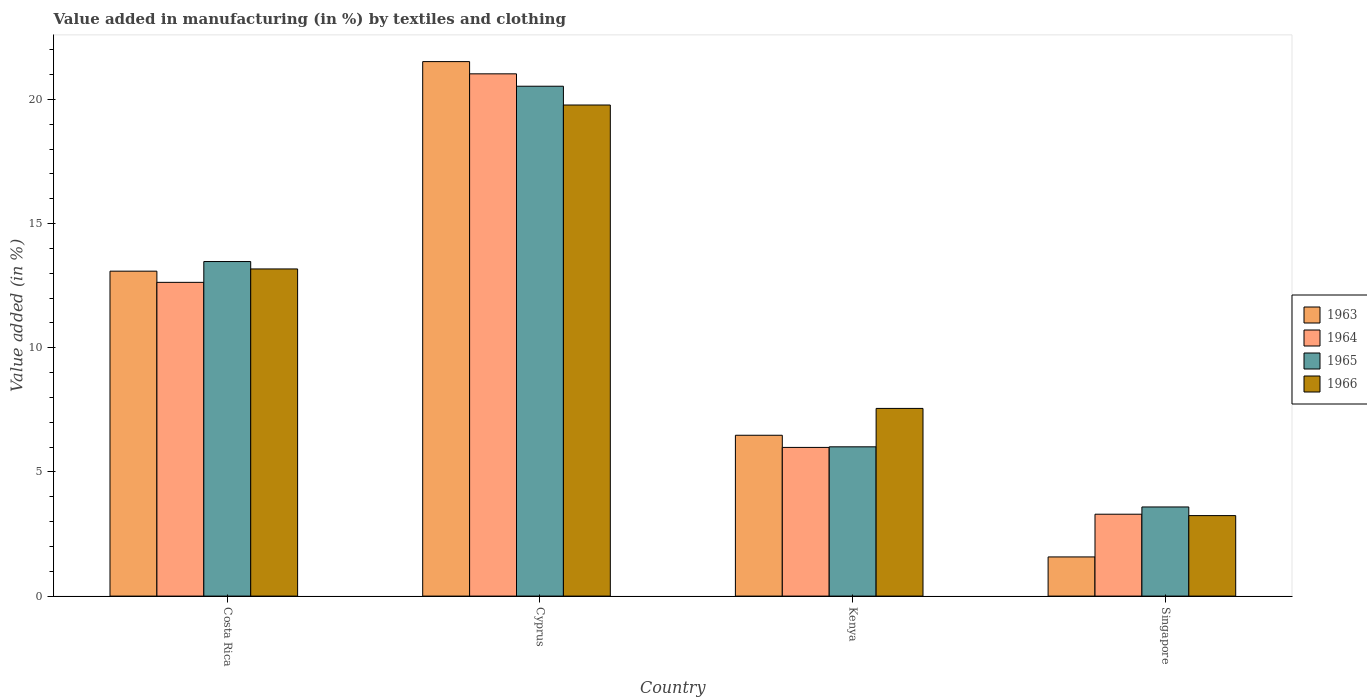How many bars are there on the 1st tick from the left?
Provide a succinct answer. 4. How many bars are there on the 3rd tick from the right?
Ensure brevity in your answer.  4. What is the label of the 1st group of bars from the left?
Your answer should be compact. Costa Rica. In how many cases, is the number of bars for a given country not equal to the number of legend labels?
Give a very brief answer. 0. What is the percentage of value added in manufacturing by textiles and clothing in 1964 in Kenya?
Give a very brief answer. 5.99. Across all countries, what is the maximum percentage of value added in manufacturing by textiles and clothing in 1965?
Keep it short and to the point. 20.53. Across all countries, what is the minimum percentage of value added in manufacturing by textiles and clothing in 1965?
Make the answer very short. 3.59. In which country was the percentage of value added in manufacturing by textiles and clothing in 1964 maximum?
Offer a terse response. Cyprus. In which country was the percentage of value added in manufacturing by textiles and clothing in 1965 minimum?
Provide a succinct answer. Singapore. What is the total percentage of value added in manufacturing by textiles and clothing in 1964 in the graph?
Give a very brief answer. 42.95. What is the difference between the percentage of value added in manufacturing by textiles and clothing in 1965 in Cyprus and that in Kenya?
Ensure brevity in your answer.  14.52. What is the difference between the percentage of value added in manufacturing by textiles and clothing in 1964 in Costa Rica and the percentage of value added in manufacturing by textiles and clothing in 1965 in Cyprus?
Provide a short and direct response. -7.9. What is the average percentage of value added in manufacturing by textiles and clothing in 1966 per country?
Offer a terse response. 10.94. What is the difference between the percentage of value added in manufacturing by textiles and clothing of/in 1963 and percentage of value added in manufacturing by textiles and clothing of/in 1964 in Cyprus?
Offer a very short reply. 0.49. In how many countries, is the percentage of value added in manufacturing by textiles and clothing in 1965 greater than 6 %?
Offer a terse response. 3. What is the ratio of the percentage of value added in manufacturing by textiles and clothing in 1964 in Costa Rica to that in Kenya?
Offer a very short reply. 2.11. Is the percentage of value added in manufacturing by textiles and clothing in 1966 in Cyprus less than that in Singapore?
Make the answer very short. No. What is the difference between the highest and the second highest percentage of value added in manufacturing by textiles and clothing in 1964?
Offer a very short reply. -6.65. What is the difference between the highest and the lowest percentage of value added in manufacturing by textiles and clothing in 1963?
Ensure brevity in your answer.  19.95. In how many countries, is the percentage of value added in manufacturing by textiles and clothing in 1965 greater than the average percentage of value added in manufacturing by textiles and clothing in 1965 taken over all countries?
Keep it short and to the point. 2. Is the sum of the percentage of value added in manufacturing by textiles and clothing in 1965 in Cyprus and Singapore greater than the maximum percentage of value added in manufacturing by textiles and clothing in 1964 across all countries?
Your response must be concise. Yes. What does the 2nd bar from the left in Singapore represents?
Offer a terse response. 1964. How many bars are there?
Ensure brevity in your answer.  16. Are all the bars in the graph horizontal?
Offer a very short reply. No. How many countries are there in the graph?
Provide a succinct answer. 4. Does the graph contain any zero values?
Keep it short and to the point. No. Does the graph contain grids?
Offer a terse response. No. Where does the legend appear in the graph?
Provide a succinct answer. Center right. How are the legend labels stacked?
Offer a terse response. Vertical. What is the title of the graph?
Your answer should be very brief. Value added in manufacturing (in %) by textiles and clothing. Does "1966" appear as one of the legend labels in the graph?
Provide a succinct answer. Yes. What is the label or title of the X-axis?
Provide a succinct answer. Country. What is the label or title of the Y-axis?
Provide a short and direct response. Value added (in %). What is the Value added (in %) of 1963 in Costa Rica?
Your response must be concise. 13.08. What is the Value added (in %) in 1964 in Costa Rica?
Ensure brevity in your answer.  12.63. What is the Value added (in %) of 1965 in Costa Rica?
Offer a very short reply. 13.47. What is the Value added (in %) in 1966 in Costa Rica?
Keep it short and to the point. 13.17. What is the Value added (in %) in 1963 in Cyprus?
Give a very brief answer. 21.52. What is the Value added (in %) of 1964 in Cyprus?
Give a very brief answer. 21.03. What is the Value added (in %) in 1965 in Cyprus?
Your answer should be very brief. 20.53. What is the Value added (in %) in 1966 in Cyprus?
Offer a very short reply. 19.78. What is the Value added (in %) in 1963 in Kenya?
Offer a very short reply. 6.48. What is the Value added (in %) of 1964 in Kenya?
Provide a short and direct response. 5.99. What is the Value added (in %) of 1965 in Kenya?
Provide a succinct answer. 6.01. What is the Value added (in %) of 1966 in Kenya?
Offer a very short reply. 7.56. What is the Value added (in %) in 1963 in Singapore?
Offer a terse response. 1.58. What is the Value added (in %) of 1964 in Singapore?
Give a very brief answer. 3.3. What is the Value added (in %) of 1965 in Singapore?
Make the answer very short. 3.59. What is the Value added (in %) of 1966 in Singapore?
Keep it short and to the point. 3.24. Across all countries, what is the maximum Value added (in %) in 1963?
Make the answer very short. 21.52. Across all countries, what is the maximum Value added (in %) of 1964?
Make the answer very short. 21.03. Across all countries, what is the maximum Value added (in %) in 1965?
Provide a short and direct response. 20.53. Across all countries, what is the maximum Value added (in %) in 1966?
Give a very brief answer. 19.78. Across all countries, what is the minimum Value added (in %) in 1963?
Offer a very short reply. 1.58. Across all countries, what is the minimum Value added (in %) in 1964?
Offer a terse response. 3.3. Across all countries, what is the minimum Value added (in %) of 1965?
Your response must be concise. 3.59. Across all countries, what is the minimum Value added (in %) in 1966?
Your response must be concise. 3.24. What is the total Value added (in %) of 1963 in the graph?
Offer a very short reply. 42.66. What is the total Value added (in %) in 1964 in the graph?
Your answer should be compact. 42.95. What is the total Value added (in %) of 1965 in the graph?
Provide a short and direct response. 43.6. What is the total Value added (in %) in 1966 in the graph?
Ensure brevity in your answer.  43.75. What is the difference between the Value added (in %) of 1963 in Costa Rica and that in Cyprus?
Keep it short and to the point. -8.44. What is the difference between the Value added (in %) in 1964 in Costa Rica and that in Cyprus?
Offer a terse response. -8.4. What is the difference between the Value added (in %) of 1965 in Costa Rica and that in Cyprus?
Keep it short and to the point. -7.06. What is the difference between the Value added (in %) of 1966 in Costa Rica and that in Cyprus?
Your answer should be compact. -6.6. What is the difference between the Value added (in %) in 1963 in Costa Rica and that in Kenya?
Offer a very short reply. 6.61. What is the difference between the Value added (in %) in 1964 in Costa Rica and that in Kenya?
Ensure brevity in your answer.  6.65. What is the difference between the Value added (in %) in 1965 in Costa Rica and that in Kenya?
Ensure brevity in your answer.  7.46. What is the difference between the Value added (in %) in 1966 in Costa Rica and that in Kenya?
Provide a short and direct response. 5.62. What is the difference between the Value added (in %) in 1963 in Costa Rica and that in Singapore?
Offer a very short reply. 11.51. What is the difference between the Value added (in %) of 1964 in Costa Rica and that in Singapore?
Provide a short and direct response. 9.34. What is the difference between the Value added (in %) of 1965 in Costa Rica and that in Singapore?
Your response must be concise. 9.88. What is the difference between the Value added (in %) of 1966 in Costa Rica and that in Singapore?
Ensure brevity in your answer.  9.93. What is the difference between the Value added (in %) in 1963 in Cyprus and that in Kenya?
Ensure brevity in your answer.  15.05. What is the difference between the Value added (in %) of 1964 in Cyprus and that in Kenya?
Offer a very short reply. 15.04. What is the difference between the Value added (in %) of 1965 in Cyprus and that in Kenya?
Provide a succinct answer. 14.52. What is the difference between the Value added (in %) in 1966 in Cyprus and that in Kenya?
Keep it short and to the point. 12.22. What is the difference between the Value added (in %) of 1963 in Cyprus and that in Singapore?
Provide a short and direct response. 19.95. What is the difference between the Value added (in %) in 1964 in Cyprus and that in Singapore?
Offer a terse response. 17.73. What is the difference between the Value added (in %) of 1965 in Cyprus and that in Singapore?
Make the answer very short. 16.94. What is the difference between the Value added (in %) of 1966 in Cyprus and that in Singapore?
Your answer should be compact. 16.53. What is the difference between the Value added (in %) in 1963 in Kenya and that in Singapore?
Your answer should be compact. 4.9. What is the difference between the Value added (in %) of 1964 in Kenya and that in Singapore?
Ensure brevity in your answer.  2.69. What is the difference between the Value added (in %) in 1965 in Kenya and that in Singapore?
Provide a succinct answer. 2.42. What is the difference between the Value added (in %) in 1966 in Kenya and that in Singapore?
Provide a short and direct response. 4.32. What is the difference between the Value added (in %) of 1963 in Costa Rica and the Value added (in %) of 1964 in Cyprus?
Your answer should be compact. -7.95. What is the difference between the Value added (in %) of 1963 in Costa Rica and the Value added (in %) of 1965 in Cyprus?
Make the answer very short. -7.45. What is the difference between the Value added (in %) in 1963 in Costa Rica and the Value added (in %) in 1966 in Cyprus?
Offer a very short reply. -6.69. What is the difference between the Value added (in %) in 1964 in Costa Rica and the Value added (in %) in 1965 in Cyprus?
Provide a short and direct response. -7.9. What is the difference between the Value added (in %) of 1964 in Costa Rica and the Value added (in %) of 1966 in Cyprus?
Offer a terse response. -7.14. What is the difference between the Value added (in %) in 1965 in Costa Rica and the Value added (in %) in 1966 in Cyprus?
Your response must be concise. -6.3. What is the difference between the Value added (in %) of 1963 in Costa Rica and the Value added (in %) of 1964 in Kenya?
Provide a succinct answer. 7.1. What is the difference between the Value added (in %) of 1963 in Costa Rica and the Value added (in %) of 1965 in Kenya?
Offer a very short reply. 7.07. What is the difference between the Value added (in %) in 1963 in Costa Rica and the Value added (in %) in 1966 in Kenya?
Keep it short and to the point. 5.53. What is the difference between the Value added (in %) of 1964 in Costa Rica and the Value added (in %) of 1965 in Kenya?
Make the answer very short. 6.62. What is the difference between the Value added (in %) in 1964 in Costa Rica and the Value added (in %) in 1966 in Kenya?
Your answer should be very brief. 5.08. What is the difference between the Value added (in %) in 1965 in Costa Rica and the Value added (in %) in 1966 in Kenya?
Offer a very short reply. 5.91. What is the difference between the Value added (in %) of 1963 in Costa Rica and the Value added (in %) of 1964 in Singapore?
Your answer should be compact. 9.79. What is the difference between the Value added (in %) in 1963 in Costa Rica and the Value added (in %) in 1965 in Singapore?
Give a very brief answer. 9.5. What is the difference between the Value added (in %) in 1963 in Costa Rica and the Value added (in %) in 1966 in Singapore?
Ensure brevity in your answer.  9.84. What is the difference between the Value added (in %) of 1964 in Costa Rica and the Value added (in %) of 1965 in Singapore?
Keep it short and to the point. 9.04. What is the difference between the Value added (in %) in 1964 in Costa Rica and the Value added (in %) in 1966 in Singapore?
Keep it short and to the point. 9.39. What is the difference between the Value added (in %) of 1965 in Costa Rica and the Value added (in %) of 1966 in Singapore?
Your answer should be compact. 10.23. What is the difference between the Value added (in %) in 1963 in Cyprus and the Value added (in %) in 1964 in Kenya?
Give a very brief answer. 15.54. What is the difference between the Value added (in %) of 1963 in Cyprus and the Value added (in %) of 1965 in Kenya?
Make the answer very short. 15.51. What is the difference between the Value added (in %) in 1963 in Cyprus and the Value added (in %) in 1966 in Kenya?
Your answer should be very brief. 13.97. What is the difference between the Value added (in %) of 1964 in Cyprus and the Value added (in %) of 1965 in Kenya?
Keep it short and to the point. 15.02. What is the difference between the Value added (in %) of 1964 in Cyprus and the Value added (in %) of 1966 in Kenya?
Provide a succinct answer. 13.47. What is the difference between the Value added (in %) of 1965 in Cyprus and the Value added (in %) of 1966 in Kenya?
Offer a terse response. 12.97. What is the difference between the Value added (in %) of 1963 in Cyprus and the Value added (in %) of 1964 in Singapore?
Offer a terse response. 18.23. What is the difference between the Value added (in %) of 1963 in Cyprus and the Value added (in %) of 1965 in Singapore?
Provide a succinct answer. 17.93. What is the difference between the Value added (in %) in 1963 in Cyprus and the Value added (in %) in 1966 in Singapore?
Your response must be concise. 18.28. What is the difference between the Value added (in %) in 1964 in Cyprus and the Value added (in %) in 1965 in Singapore?
Give a very brief answer. 17.44. What is the difference between the Value added (in %) in 1964 in Cyprus and the Value added (in %) in 1966 in Singapore?
Your answer should be very brief. 17.79. What is the difference between the Value added (in %) of 1965 in Cyprus and the Value added (in %) of 1966 in Singapore?
Provide a short and direct response. 17.29. What is the difference between the Value added (in %) of 1963 in Kenya and the Value added (in %) of 1964 in Singapore?
Your answer should be compact. 3.18. What is the difference between the Value added (in %) of 1963 in Kenya and the Value added (in %) of 1965 in Singapore?
Offer a terse response. 2.89. What is the difference between the Value added (in %) of 1963 in Kenya and the Value added (in %) of 1966 in Singapore?
Your answer should be very brief. 3.24. What is the difference between the Value added (in %) in 1964 in Kenya and the Value added (in %) in 1965 in Singapore?
Your response must be concise. 2.4. What is the difference between the Value added (in %) in 1964 in Kenya and the Value added (in %) in 1966 in Singapore?
Offer a terse response. 2.75. What is the difference between the Value added (in %) in 1965 in Kenya and the Value added (in %) in 1966 in Singapore?
Ensure brevity in your answer.  2.77. What is the average Value added (in %) in 1963 per country?
Your answer should be compact. 10.67. What is the average Value added (in %) of 1964 per country?
Your response must be concise. 10.74. What is the average Value added (in %) in 1965 per country?
Your answer should be very brief. 10.9. What is the average Value added (in %) in 1966 per country?
Provide a succinct answer. 10.94. What is the difference between the Value added (in %) in 1963 and Value added (in %) in 1964 in Costa Rica?
Offer a terse response. 0.45. What is the difference between the Value added (in %) in 1963 and Value added (in %) in 1965 in Costa Rica?
Make the answer very short. -0.39. What is the difference between the Value added (in %) in 1963 and Value added (in %) in 1966 in Costa Rica?
Make the answer very short. -0.09. What is the difference between the Value added (in %) of 1964 and Value added (in %) of 1965 in Costa Rica?
Offer a very short reply. -0.84. What is the difference between the Value added (in %) in 1964 and Value added (in %) in 1966 in Costa Rica?
Provide a short and direct response. -0.54. What is the difference between the Value added (in %) of 1965 and Value added (in %) of 1966 in Costa Rica?
Ensure brevity in your answer.  0.3. What is the difference between the Value added (in %) in 1963 and Value added (in %) in 1964 in Cyprus?
Provide a short and direct response. 0.49. What is the difference between the Value added (in %) of 1963 and Value added (in %) of 1965 in Cyprus?
Provide a succinct answer. 0.99. What is the difference between the Value added (in %) of 1963 and Value added (in %) of 1966 in Cyprus?
Your answer should be compact. 1.75. What is the difference between the Value added (in %) in 1964 and Value added (in %) in 1965 in Cyprus?
Keep it short and to the point. 0.5. What is the difference between the Value added (in %) of 1964 and Value added (in %) of 1966 in Cyprus?
Your answer should be compact. 1.25. What is the difference between the Value added (in %) of 1965 and Value added (in %) of 1966 in Cyprus?
Your answer should be very brief. 0.76. What is the difference between the Value added (in %) of 1963 and Value added (in %) of 1964 in Kenya?
Keep it short and to the point. 0.49. What is the difference between the Value added (in %) of 1963 and Value added (in %) of 1965 in Kenya?
Your answer should be compact. 0.47. What is the difference between the Value added (in %) in 1963 and Value added (in %) in 1966 in Kenya?
Offer a terse response. -1.08. What is the difference between the Value added (in %) of 1964 and Value added (in %) of 1965 in Kenya?
Your answer should be very brief. -0.02. What is the difference between the Value added (in %) of 1964 and Value added (in %) of 1966 in Kenya?
Give a very brief answer. -1.57. What is the difference between the Value added (in %) of 1965 and Value added (in %) of 1966 in Kenya?
Provide a short and direct response. -1.55. What is the difference between the Value added (in %) of 1963 and Value added (in %) of 1964 in Singapore?
Your answer should be compact. -1.72. What is the difference between the Value added (in %) of 1963 and Value added (in %) of 1965 in Singapore?
Your answer should be compact. -2.01. What is the difference between the Value added (in %) in 1963 and Value added (in %) in 1966 in Singapore?
Provide a short and direct response. -1.66. What is the difference between the Value added (in %) of 1964 and Value added (in %) of 1965 in Singapore?
Your answer should be very brief. -0.29. What is the difference between the Value added (in %) of 1964 and Value added (in %) of 1966 in Singapore?
Provide a short and direct response. 0.06. What is the difference between the Value added (in %) in 1965 and Value added (in %) in 1966 in Singapore?
Make the answer very short. 0.35. What is the ratio of the Value added (in %) in 1963 in Costa Rica to that in Cyprus?
Keep it short and to the point. 0.61. What is the ratio of the Value added (in %) of 1964 in Costa Rica to that in Cyprus?
Your response must be concise. 0.6. What is the ratio of the Value added (in %) in 1965 in Costa Rica to that in Cyprus?
Keep it short and to the point. 0.66. What is the ratio of the Value added (in %) of 1966 in Costa Rica to that in Cyprus?
Offer a terse response. 0.67. What is the ratio of the Value added (in %) in 1963 in Costa Rica to that in Kenya?
Ensure brevity in your answer.  2.02. What is the ratio of the Value added (in %) in 1964 in Costa Rica to that in Kenya?
Provide a short and direct response. 2.11. What is the ratio of the Value added (in %) in 1965 in Costa Rica to that in Kenya?
Provide a short and direct response. 2.24. What is the ratio of the Value added (in %) in 1966 in Costa Rica to that in Kenya?
Provide a succinct answer. 1.74. What is the ratio of the Value added (in %) in 1963 in Costa Rica to that in Singapore?
Keep it short and to the point. 8.3. What is the ratio of the Value added (in %) in 1964 in Costa Rica to that in Singapore?
Offer a terse response. 3.83. What is the ratio of the Value added (in %) in 1965 in Costa Rica to that in Singapore?
Your answer should be very brief. 3.75. What is the ratio of the Value added (in %) of 1966 in Costa Rica to that in Singapore?
Give a very brief answer. 4.06. What is the ratio of the Value added (in %) in 1963 in Cyprus to that in Kenya?
Ensure brevity in your answer.  3.32. What is the ratio of the Value added (in %) in 1964 in Cyprus to that in Kenya?
Offer a very short reply. 3.51. What is the ratio of the Value added (in %) of 1965 in Cyprus to that in Kenya?
Your answer should be compact. 3.42. What is the ratio of the Value added (in %) in 1966 in Cyprus to that in Kenya?
Keep it short and to the point. 2.62. What is the ratio of the Value added (in %) in 1963 in Cyprus to that in Singapore?
Ensure brevity in your answer.  13.65. What is the ratio of the Value added (in %) in 1964 in Cyprus to that in Singapore?
Keep it short and to the point. 6.38. What is the ratio of the Value added (in %) of 1965 in Cyprus to that in Singapore?
Ensure brevity in your answer.  5.72. What is the ratio of the Value added (in %) in 1966 in Cyprus to that in Singapore?
Your answer should be compact. 6.1. What is the ratio of the Value added (in %) in 1963 in Kenya to that in Singapore?
Offer a terse response. 4.11. What is the ratio of the Value added (in %) in 1964 in Kenya to that in Singapore?
Keep it short and to the point. 1.82. What is the ratio of the Value added (in %) in 1965 in Kenya to that in Singapore?
Make the answer very short. 1.67. What is the ratio of the Value added (in %) of 1966 in Kenya to that in Singapore?
Offer a very short reply. 2.33. What is the difference between the highest and the second highest Value added (in %) in 1963?
Give a very brief answer. 8.44. What is the difference between the highest and the second highest Value added (in %) in 1964?
Your answer should be compact. 8.4. What is the difference between the highest and the second highest Value added (in %) of 1965?
Your answer should be compact. 7.06. What is the difference between the highest and the second highest Value added (in %) in 1966?
Provide a succinct answer. 6.6. What is the difference between the highest and the lowest Value added (in %) in 1963?
Provide a short and direct response. 19.95. What is the difference between the highest and the lowest Value added (in %) of 1964?
Keep it short and to the point. 17.73. What is the difference between the highest and the lowest Value added (in %) in 1965?
Offer a terse response. 16.94. What is the difference between the highest and the lowest Value added (in %) in 1966?
Your answer should be very brief. 16.53. 